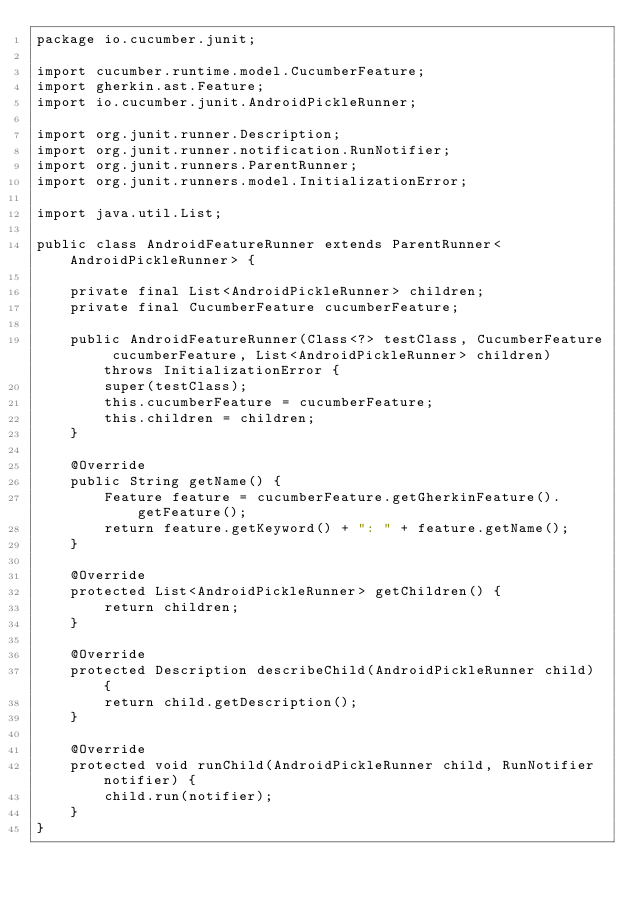<code> <loc_0><loc_0><loc_500><loc_500><_Java_>package io.cucumber.junit;

import cucumber.runtime.model.CucumberFeature;
import gherkin.ast.Feature;
import io.cucumber.junit.AndroidPickleRunner;

import org.junit.runner.Description;
import org.junit.runner.notification.RunNotifier;
import org.junit.runners.ParentRunner;
import org.junit.runners.model.InitializationError;

import java.util.List;

public class AndroidFeatureRunner extends ParentRunner<AndroidPickleRunner> {

	private final List<AndroidPickleRunner> children;
	private final CucumberFeature cucumberFeature;

	public AndroidFeatureRunner(Class<?> testClass, CucumberFeature cucumberFeature, List<AndroidPickleRunner> children) throws InitializationError	{
		super(testClass);
		this.cucumberFeature = cucumberFeature;
		this.children = children;
	}

	@Override
	public String getName() {
		Feature feature = cucumberFeature.getGherkinFeature().getFeature();
		return feature.getKeyword() + ": " + feature.getName();
	}

	@Override
	protected List<AndroidPickleRunner> getChildren() {
		return children;
	}

	@Override
	protected Description describeChild(AndroidPickleRunner child) {
		return child.getDescription();
	}

	@Override
	protected void runChild(AndroidPickleRunner child, RunNotifier notifier) {
		child.run(notifier);
	}
}
</code> 